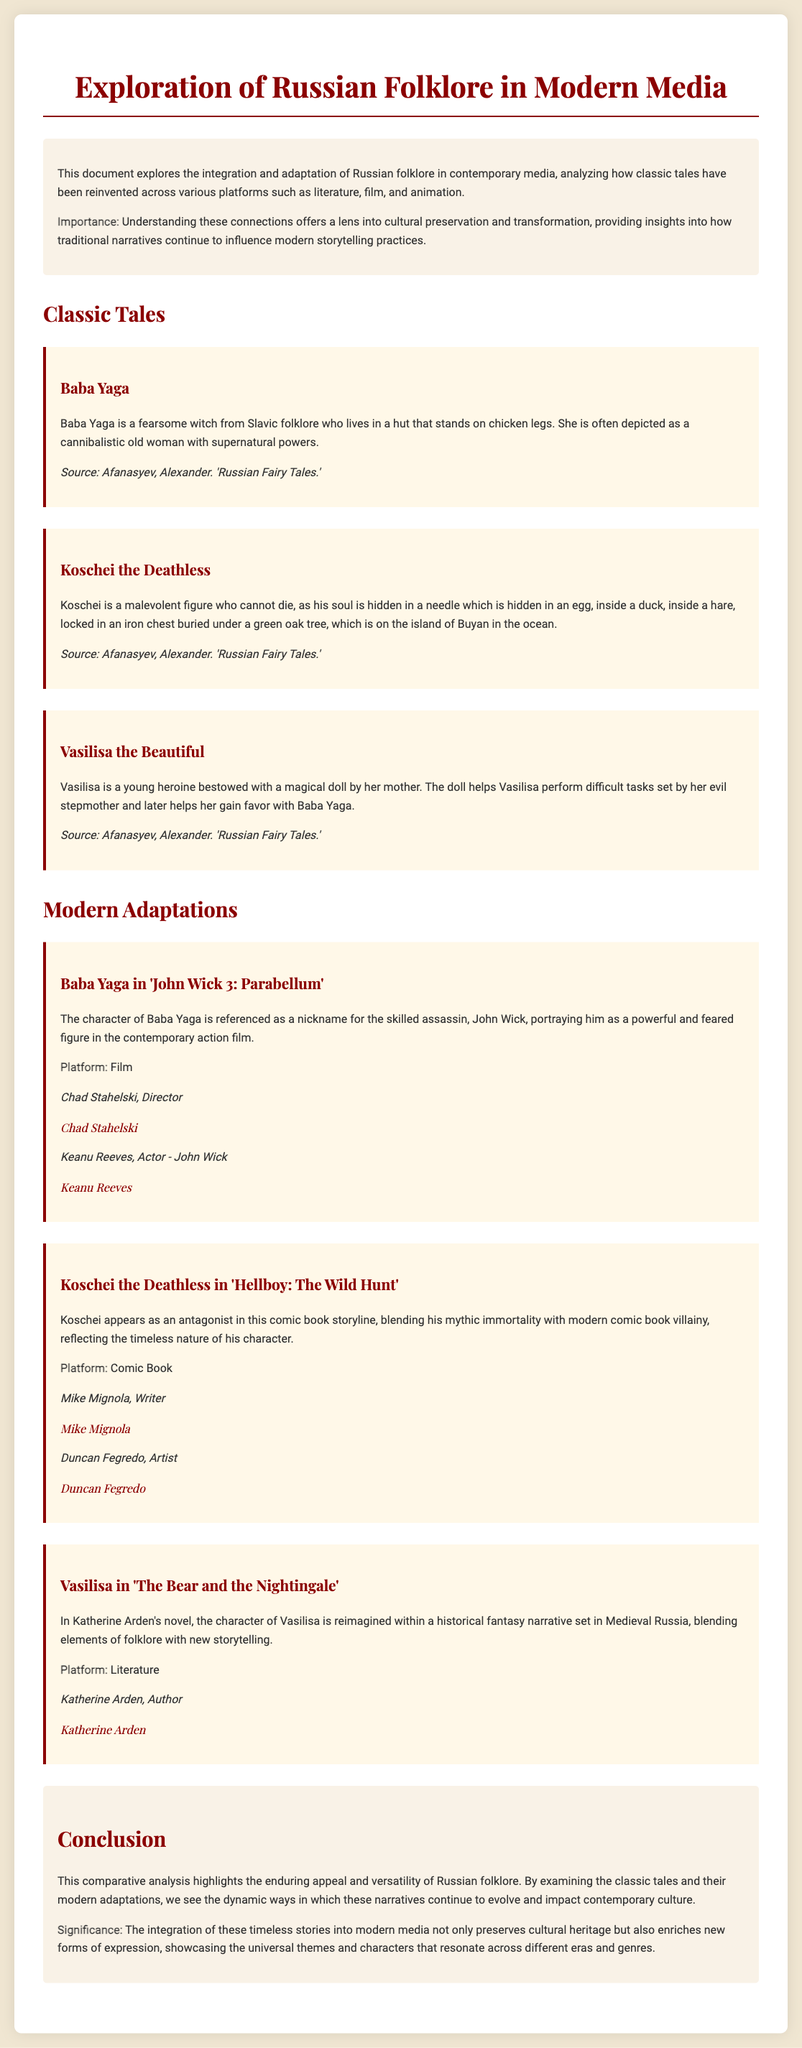What is the title of the document? The title is stated at the top of the document, which is focused on exploring Russian folklore in modern media.
Answer: Exploration of Russian Folklore in Modern Media: A Comparative Analysis Who is the author of "The Bear and the Nightingale"? The author is specifically mentioned in the section discussing the modern adaptations of Vasilisa.
Answer: Katherine Arden What character is represented as living in a hut on chicken legs? This character is described as a fearsome witch and is part of the classic tales section of the document.
Answer: Baba Yaga How many classic tales are listed in the document? The document provides a section specifically titled Classic Tales, listing three examples.
Answer: Three In which modern adaptation does Koschei appear? This refers to the section detailing the modern adaptations, specifically related to Koschei.
Answer: Hellboy: The Wild Hunt Who contributed to the film that references Baba Yaga? The contributors to the adaptation involving Baba Yaga are mentioned in that specific section.
Answer: Chad Stahelski and Keanu Reeves What is one significance of integrating folklore into modern media mentioned in the conclusion? The conclusion emphasizes the impact of modern media in preserving cultural heritage.
Answer: Preserves cultural heritage Which platform features Vasilisa in a historical fantasy narrative? The document provides information on various platforms where adaptations are found, making it clear for Vasilisa.
Answer: Literature 